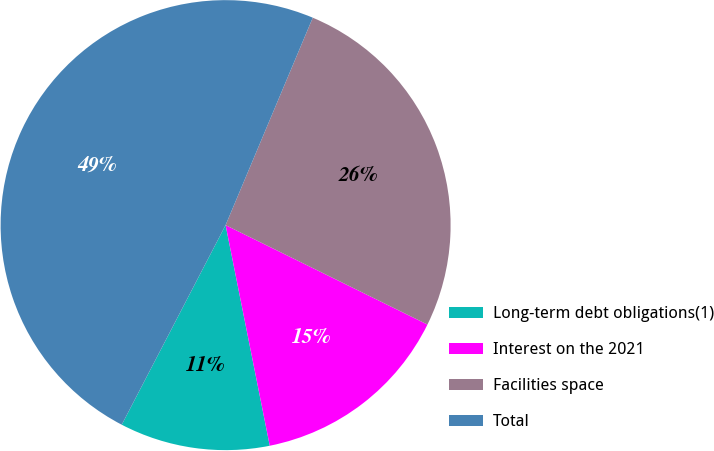Convert chart. <chart><loc_0><loc_0><loc_500><loc_500><pie_chart><fcel>Long-term debt obligations(1)<fcel>Interest on the 2021<fcel>Facilities space<fcel>Total<nl><fcel>10.78%<fcel>14.57%<fcel>25.95%<fcel>48.69%<nl></chart> 